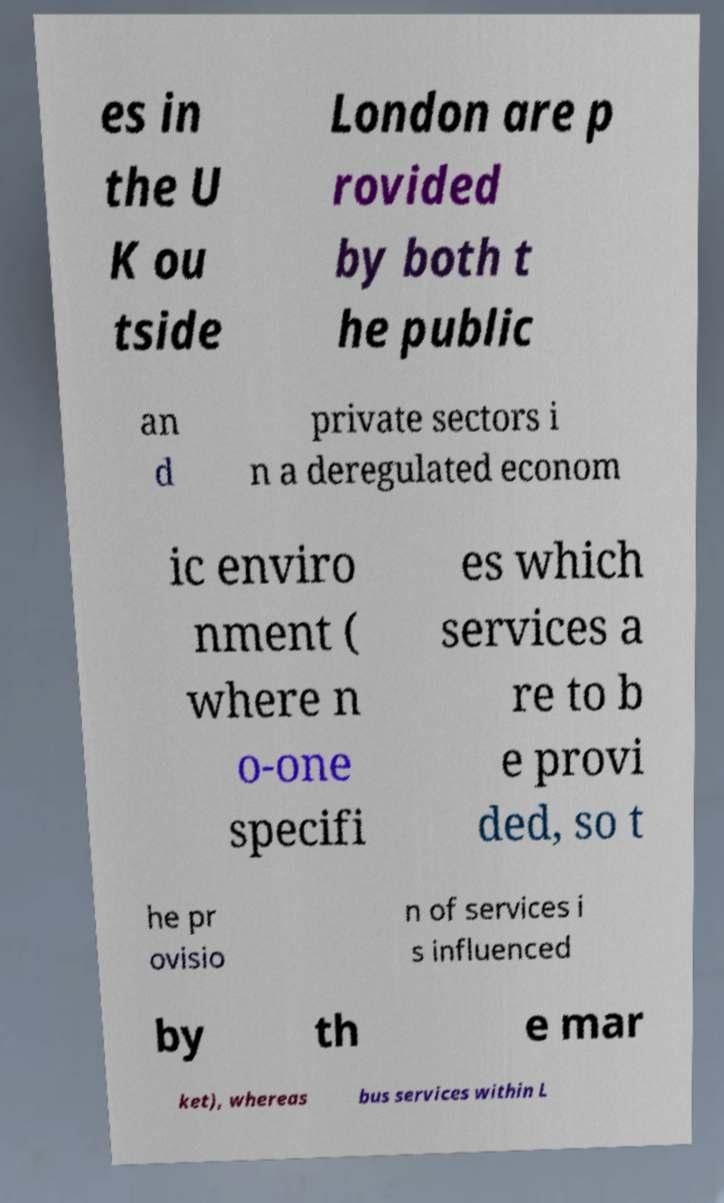Could you assist in decoding the text presented in this image and type it out clearly? es in the U K ou tside London are p rovided by both t he public an d private sectors i n a deregulated econom ic enviro nment ( where n o-one specifi es which services a re to b e provi ded, so t he pr ovisio n of services i s influenced by th e mar ket), whereas bus services within L 